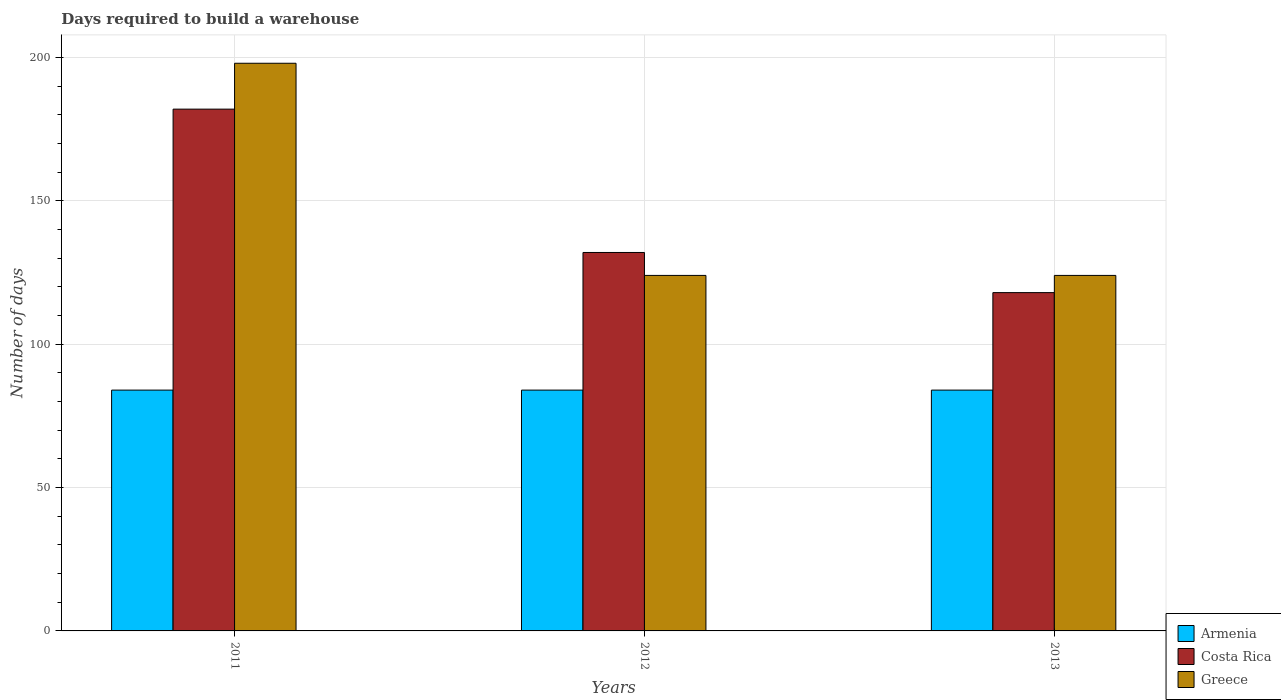How many different coloured bars are there?
Ensure brevity in your answer.  3. How many groups of bars are there?
Keep it short and to the point. 3. What is the label of the 3rd group of bars from the left?
Your answer should be very brief. 2013. What is the days required to build a warehouse in in Greece in 2012?
Your response must be concise. 124. Across all years, what is the maximum days required to build a warehouse in in Costa Rica?
Ensure brevity in your answer.  182. Across all years, what is the minimum days required to build a warehouse in in Greece?
Give a very brief answer. 124. In which year was the days required to build a warehouse in in Armenia maximum?
Provide a short and direct response. 2011. In which year was the days required to build a warehouse in in Greece minimum?
Provide a short and direct response. 2012. What is the total days required to build a warehouse in in Armenia in the graph?
Your answer should be compact. 252. What is the difference between the days required to build a warehouse in in Costa Rica in 2011 and that in 2012?
Provide a succinct answer. 50. What is the difference between the days required to build a warehouse in in Armenia in 2012 and the days required to build a warehouse in in Greece in 2013?
Your answer should be very brief. -40. What is the average days required to build a warehouse in in Costa Rica per year?
Your response must be concise. 144. In the year 2011, what is the difference between the days required to build a warehouse in in Costa Rica and days required to build a warehouse in in Greece?
Keep it short and to the point. -16. What is the ratio of the days required to build a warehouse in in Greece in 2011 to that in 2012?
Ensure brevity in your answer.  1.6. Is the difference between the days required to build a warehouse in in Costa Rica in 2011 and 2012 greater than the difference between the days required to build a warehouse in in Greece in 2011 and 2012?
Give a very brief answer. No. What is the difference between the highest and the lowest days required to build a warehouse in in Greece?
Your answer should be compact. 74. In how many years, is the days required to build a warehouse in in Greece greater than the average days required to build a warehouse in in Greece taken over all years?
Provide a succinct answer. 1. What does the 3rd bar from the right in 2012 represents?
Offer a terse response. Armenia. How many bars are there?
Ensure brevity in your answer.  9. Are all the bars in the graph horizontal?
Keep it short and to the point. No. How many years are there in the graph?
Your answer should be compact. 3. Does the graph contain any zero values?
Provide a short and direct response. No. Does the graph contain grids?
Offer a terse response. Yes. Where does the legend appear in the graph?
Your answer should be very brief. Bottom right. How many legend labels are there?
Your answer should be very brief. 3. How are the legend labels stacked?
Ensure brevity in your answer.  Vertical. What is the title of the graph?
Make the answer very short. Days required to build a warehouse. Does "Guatemala" appear as one of the legend labels in the graph?
Offer a terse response. No. What is the label or title of the X-axis?
Offer a terse response. Years. What is the label or title of the Y-axis?
Ensure brevity in your answer.  Number of days. What is the Number of days of Armenia in 2011?
Ensure brevity in your answer.  84. What is the Number of days of Costa Rica in 2011?
Your answer should be compact. 182. What is the Number of days in Greece in 2011?
Provide a succinct answer. 198. What is the Number of days of Armenia in 2012?
Ensure brevity in your answer.  84. What is the Number of days of Costa Rica in 2012?
Provide a succinct answer. 132. What is the Number of days in Greece in 2012?
Give a very brief answer. 124. What is the Number of days of Armenia in 2013?
Ensure brevity in your answer.  84. What is the Number of days of Costa Rica in 2013?
Provide a succinct answer. 118. What is the Number of days of Greece in 2013?
Ensure brevity in your answer.  124. Across all years, what is the maximum Number of days of Costa Rica?
Your response must be concise. 182. Across all years, what is the maximum Number of days of Greece?
Your answer should be compact. 198. Across all years, what is the minimum Number of days in Costa Rica?
Your answer should be very brief. 118. Across all years, what is the minimum Number of days of Greece?
Ensure brevity in your answer.  124. What is the total Number of days of Armenia in the graph?
Provide a short and direct response. 252. What is the total Number of days of Costa Rica in the graph?
Your answer should be compact. 432. What is the total Number of days of Greece in the graph?
Your answer should be compact. 446. What is the difference between the Number of days in Costa Rica in 2011 and that in 2012?
Your response must be concise. 50. What is the difference between the Number of days of Armenia in 2011 and that in 2013?
Your response must be concise. 0. What is the difference between the Number of days in Costa Rica in 2011 and that in 2013?
Your answer should be compact. 64. What is the difference between the Number of days of Greece in 2011 and that in 2013?
Give a very brief answer. 74. What is the difference between the Number of days of Costa Rica in 2012 and that in 2013?
Provide a short and direct response. 14. What is the difference between the Number of days in Greece in 2012 and that in 2013?
Offer a terse response. 0. What is the difference between the Number of days in Armenia in 2011 and the Number of days in Costa Rica in 2012?
Provide a short and direct response. -48. What is the difference between the Number of days in Costa Rica in 2011 and the Number of days in Greece in 2012?
Give a very brief answer. 58. What is the difference between the Number of days of Armenia in 2011 and the Number of days of Costa Rica in 2013?
Offer a very short reply. -34. What is the difference between the Number of days in Armenia in 2012 and the Number of days in Costa Rica in 2013?
Your response must be concise. -34. What is the difference between the Number of days in Costa Rica in 2012 and the Number of days in Greece in 2013?
Ensure brevity in your answer.  8. What is the average Number of days in Costa Rica per year?
Offer a very short reply. 144. What is the average Number of days in Greece per year?
Provide a succinct answer. 148.67. In the year 2011, what is the difference between the Number of days of Armenia and Number of days of Costa Rica?
Keep it short and to the point. -98. In the year 2011, what is the difference between the Number of days in Armenia and Number of days in Greece?
Provide a succinct answer. -114. In the year 2012, what is the difference between the Number of days of Armenia and Number of days of Costa Rica?
Make the answer very short. -48. In the year 2012, what is the difference between the Number of days of Armenia and Number of days of Greece?
Your response must be concise. -40. In the year 2012, what is the difference between the Number of days in Costa Rica and Number of days in Greece?
Give a very brief answer. 8. In the year 2013, what is the difference between the Number of days in Armenia and Number of days in Costa Rica?
Ensure brevity in your answer.  -34. In the year 2013, what is the difference between the Number of days of Armenia and Number of days of Greece?
Your answer should be compact. -40. In the year 2013, what is the difference between the Number of days in Costa Rica and Number of days in Greece?
Ensure brevity in your answer.  -6. What is the ratio of the Number of days in Armenia in 2011 to that in 2012?
Give a very brief answer. 1. What is the ratio of the Number of days in Costa Rica in 2011 to that in 2012?
Your answer should be compact. 1.38. What is the ratio of the Number of days of Greece in 2011 to that in 2012?
Offer a very short reply. 1.6. What is the ratio of the Number of days of Costa Rica in 2011 to that in 2013?
Provide a short and direct response. 1.54. What is the ratio of the Number of days in Greece in 2011 to that in 2013?
Give a very brief answer. 1.6. What is the ratio of the Number of days in Costa Rica in 2012 to that in 2013?
Your answer should be very brief. 1.12. What is the ratio of the Number of days in Greece in 2012 to that in 2013?
Make the answer very short. 1. What is the difference between the highest and the second highest Number of days in Armenia?
Make the answer very short. 0. What is the difference between the highest and the second highest Number of days of Costa Rica?
Give a very brief answer. 50. 